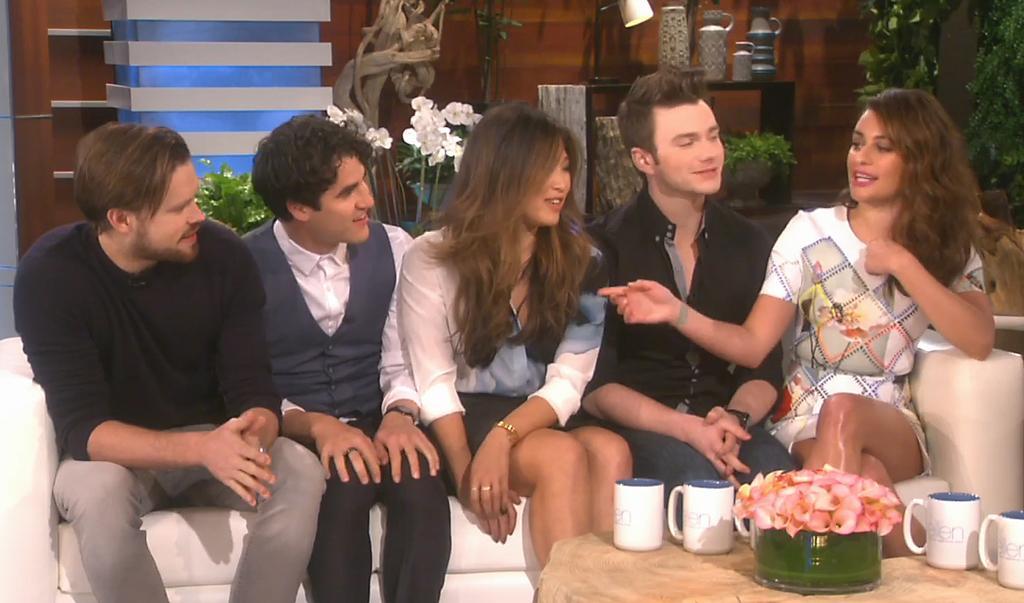In one or two sentences, can you explain what this image depicts? In this image at front there is a table and on top of it there is flower pot and four mugs. Behind the table there are a few people sitting on the sofa. On the backside there are plants. Behind the plants there is a table and on top of it there are four jars and a lamp. Behind the table there is a wall. 